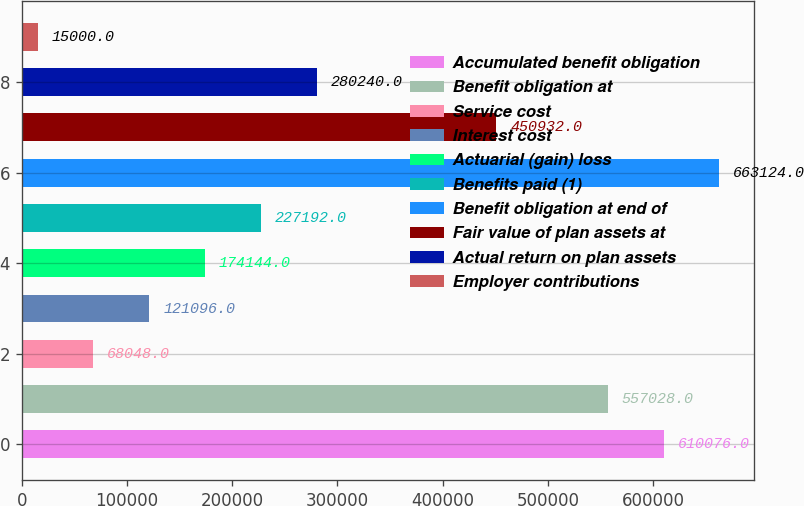Convert chart. <chart><loc_0><loc_0><loc_500><loc_500><bar_chart><fcel>Accumulated benefit obligation<fcel>Benefit obligation at<fcel>Service cost<fcel>Interest cost<fcel>Actuarial (gain) loss<fcel>Benefits paid (1)<fcel>Benefit obligation at end of<fcel>Fair value of plan assets at<fcel>Actual return on plan assets<fcel>Employer contributions<nl><fcel>610076<fcel>557028<fcel>68048<fcel>121096<fcel>174144<fcel>227192<fcel>663124<fcel>450932<fcel>280240<fcel>15000<nl></chart> 